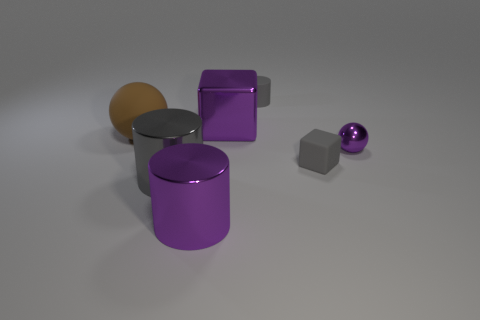Add 3 big brown matte things. How many objects exist? 10 Subtract all cubes. How many objects are left? 5 Add 6 matte cylinders. How many matte cylinders exist? 7 Subtract 0 cyan spheres. How many objects are left? 7 Subtract all gray rubber cylinders. Subtract all metallic cubes. How many objects are left? 5 Add 5 shiny blocks. How many shiny blocks are left? 6 